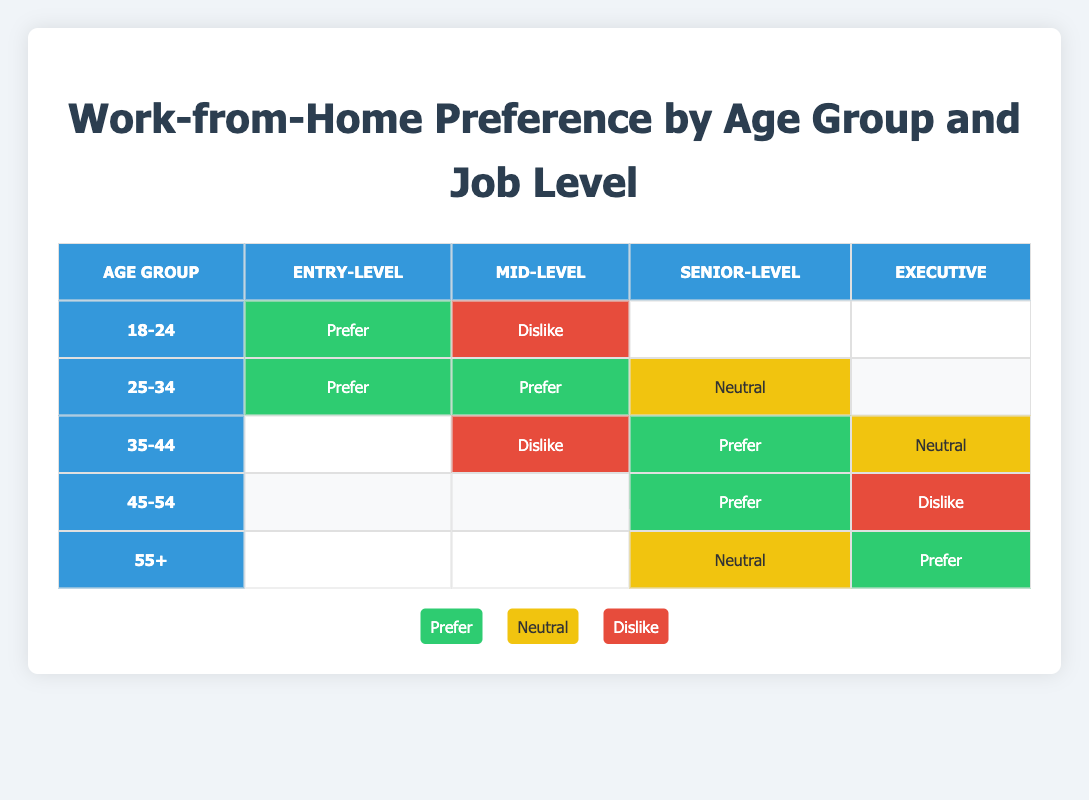What percentage of Entry-Level employees in the age group 18-24 prefer to work from home? From the table, in the age group 18-24, there are two recorded preferences for Entry-Level: 1 "Prefer" and 1 "Neutral". Since only 1 out of the 2 preferences is "Prefer", the percentage is (1/2) * 100 = 50%.
Answer: 50% How many Mid-Level employees dislike working from home? The table shows that in the Mid-Level category, there is 1 instance of "Dislike" under the age group 18-24 and another under 35-44. Adding them gives a total of 2 instances.
Answer: 2 Is there any age group for Senior-Level employees that has a neutral work-from-home preference? Under the Senior-Level category, the age group 35-44 has a "Neutral" preference. Therefore, the statement is true.
Answer: Yes Which job level has the highest preference for working from home in the age group 25-34? In the age group 25-34, both Entry-Level and Mid-Level positions have a "Prefer" preference while Senior-Level is "Neutral". Hence, Entry-Level and Mid-Level share the highest preference.
Answer: Entry-Level and Mid-Level What is the overall trend for work-from-home preferences among age groups 45-54? In the 45-54 age group, the Senior-Level preference is "Prefer", while the Executive level is "Dislike". This indicates a mixed trend but overall suggests more preference to work from home at the Senior level.
Answer: Mixed trend with a preference in Senior-Level 